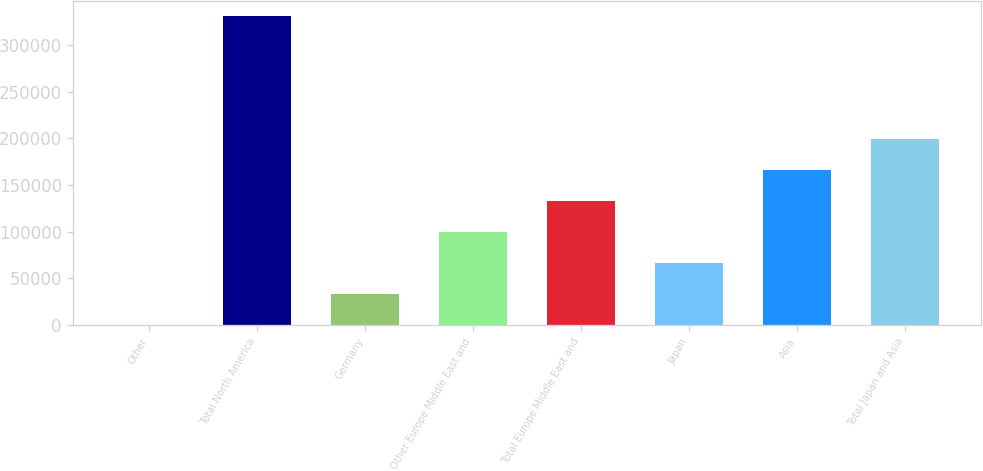Convert chart. <chart><loc_0><loc_0><loc_500><loc_500><bar_chart><fcel>Other<fcel>Total North America<fcel>Germany<fcel>Other Europe Middle East and<fcel>Total Europe Middle East and<fcel>Japan<fcel>Asia<fcel>Total Japan and Asia<nl><fcel>227<fcel>331456<fcel>33349.9<fcel>99595.7<fcel>132719<fcel>66472.8<fcel>165842<fcel>198964<nl></chart> 